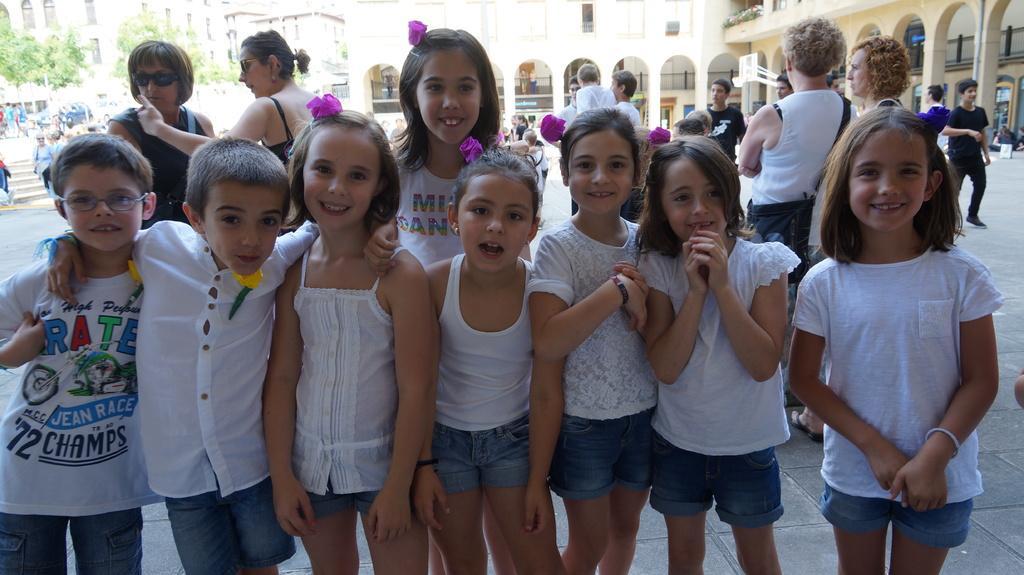In one or two sentences, can you explain what this image depicts? In this picture we can see the girls and boys who are standing in a line and they are smiling. On the left there are two women who are wearing goggles and black dress. On the left background i can see many peoples were standing near to the stars, cars and trees. In the background i can see the buildings. In the top right there is a basketball court, beside that i can see many people were standing. 